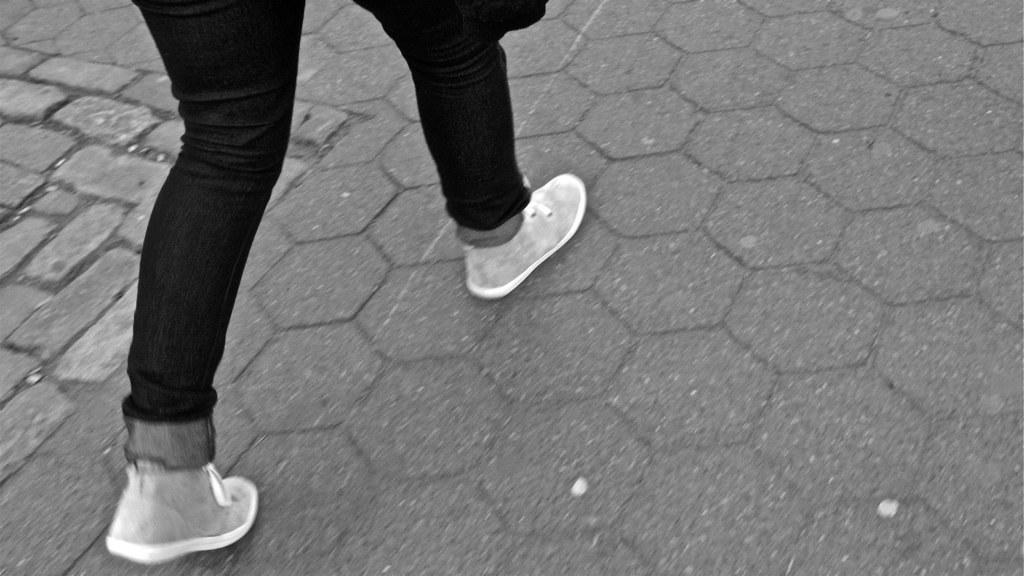What is the color scheme of the image? The image is black and white. What part of a person can be seen in the image? The legs of a person are visible in the image. What type of footwear is the person wearing? The person is wearing shoes. What can be seen beneath the person's legs in the image? The ground is visible in the image. What type of cream can be seen on the person's legs in the image? There is no cream visible on the person's legs in the image. How many snakes are slithering around the person's legs in the image? There are no snakes present in the image. 